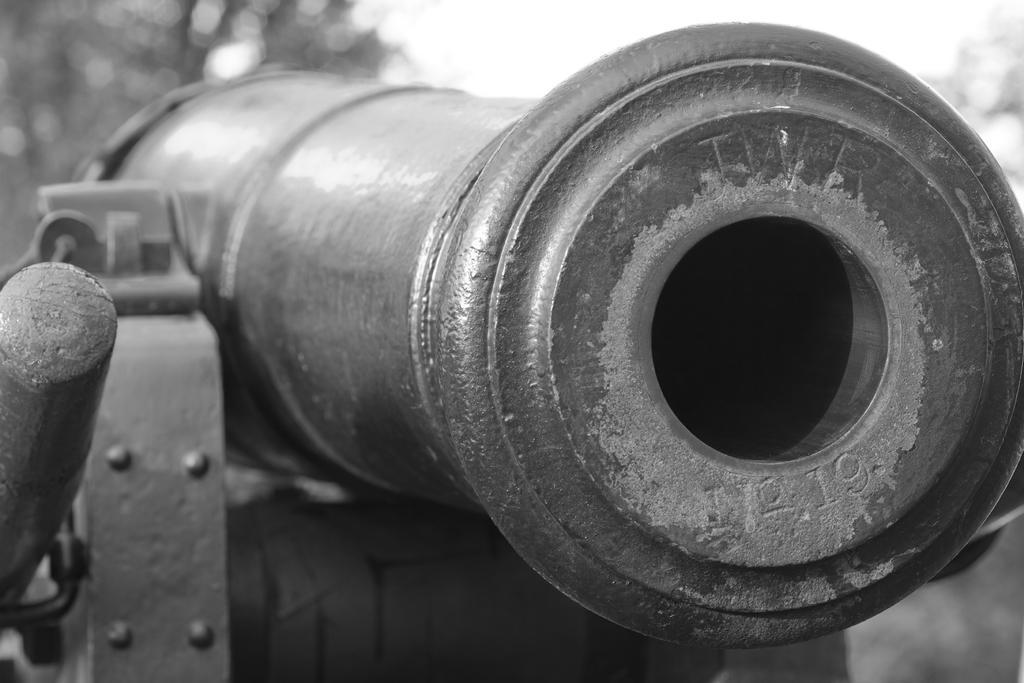Can you describe this image briefly? In this picture there is a canon. In the background I can see some trees. At the top I can see the sky. On the it might be a wooden stick. 